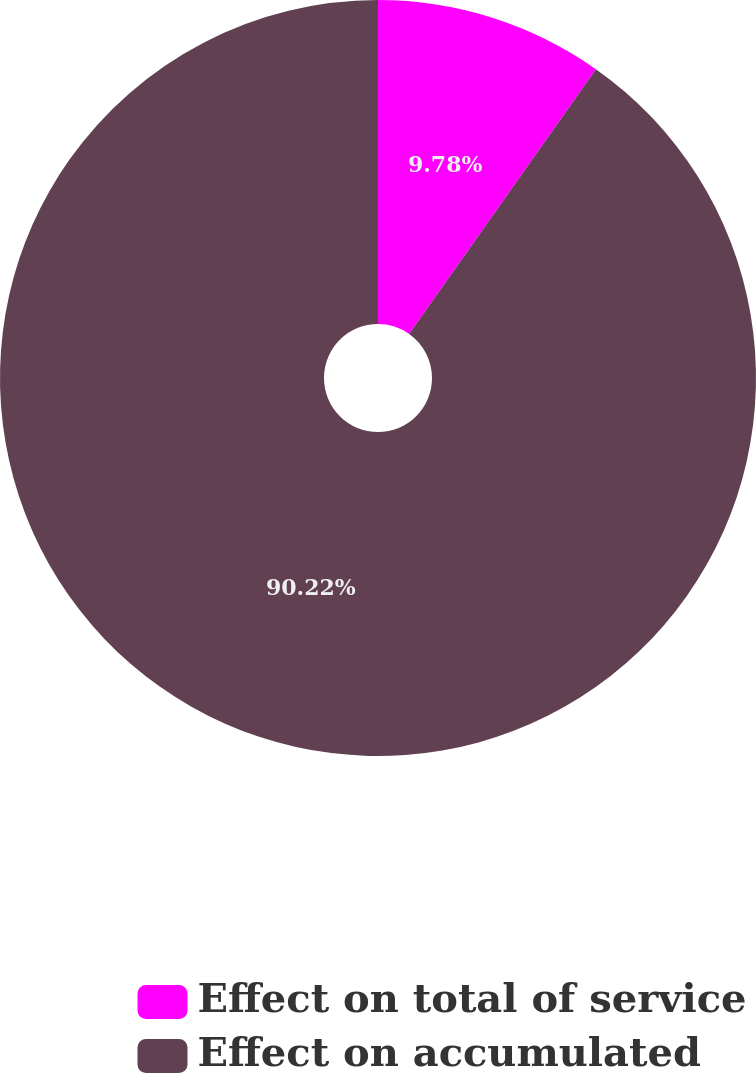Convert chart. <chart><loc_0><loc_0><loc_500><loc_500><pie_chart><fcel>Effect on total of service<fcel>Effect on accumulated<nl><fcel>9.78%<fcel>90.22%<nl></chart> 